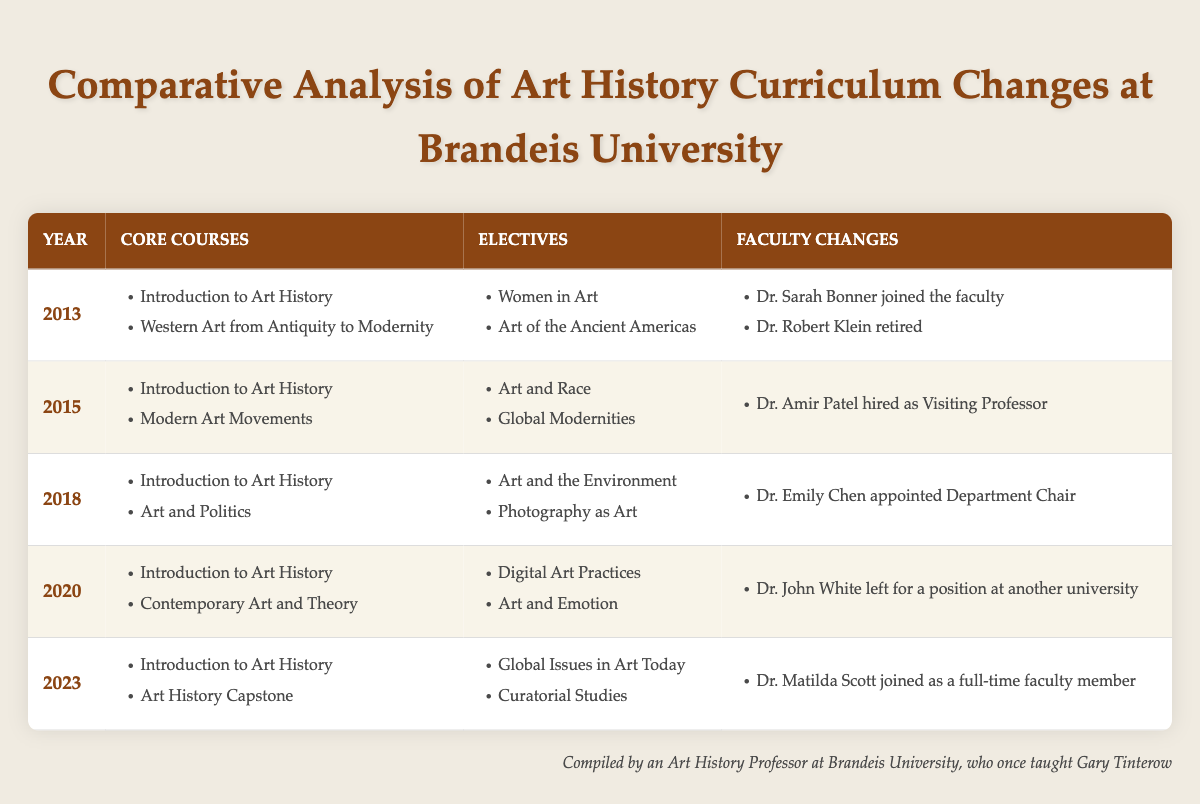What core courses were offered in 2015? The core courses listed for 2015 in the table are "Introduction to Art History" and "Modern Art Movements".
Answer: Introduction to Art History, Modern Art Movements How many faculty changes occurred between 2013 and 2023? Reviewing the faculty changes listed for each year: 2013 (2 changes), 2015 (1 change), 2018 (1 change), 2020 (1 change), and 2023 (1 change). Summing these gives 2 + 1 + 1 + 1 + 1 = 6 faculty changes.
Answer: 6 Did Dr. John White join Brandeis University during this period? The table indicates that Dr. John White left for a position at another university in 2020, and does not mention that he joined, so the answer is no.
Answer: No What was the transition in elective courses from 2018 to 2023? In 2018, the electives were "Art and the Environment" and "Photography as Art". By 2023, the electives changed to "Global Issues in Art Today" and "Curatorial Studies", indicating a shift in focus from specific mediums and themes to broader global issues and curatorial practice.
Answer: Change in focus from specific mediums to global issues and curatorial studies Which year saw the introduction of "Contemporary Art and Theory" as a core course? According to the table, "Contemporary Art and Theory" was introduced as a core course in the year 2020, as it is the only year listed with that course.
Answer: 2020 In which year did the most faculty changes occur, and how many were there? Looking through the years, the year 2013 had the highest number of faculty changes with 2 (Dr. Sarah Bonner joined and Dr. Robert Klein retired). The other years had either 1 change or none.
Answer: 2013, 2 changes How many total core courses were offered in 2018? The year 2018 had 2 core courses listed: "Introduction to Art History" and "Art and Politics". Therefore, the total number of core courses offered that year is 2.
Answer: 2 Is it true that every year had "Introduction to Art History" listed as a core course? Yes, the table confirms that "Introduction to Art History" is listed as a core course from 2013 through to 2023, meaning it was indeed present every year.
Answer: Yes What year marked the introduction of "Art History Capstone" among the core courses? According to the table, "Art History Capstone" was introduced as a core course in 2023, as it is listed under that year.
Answer: 2023 